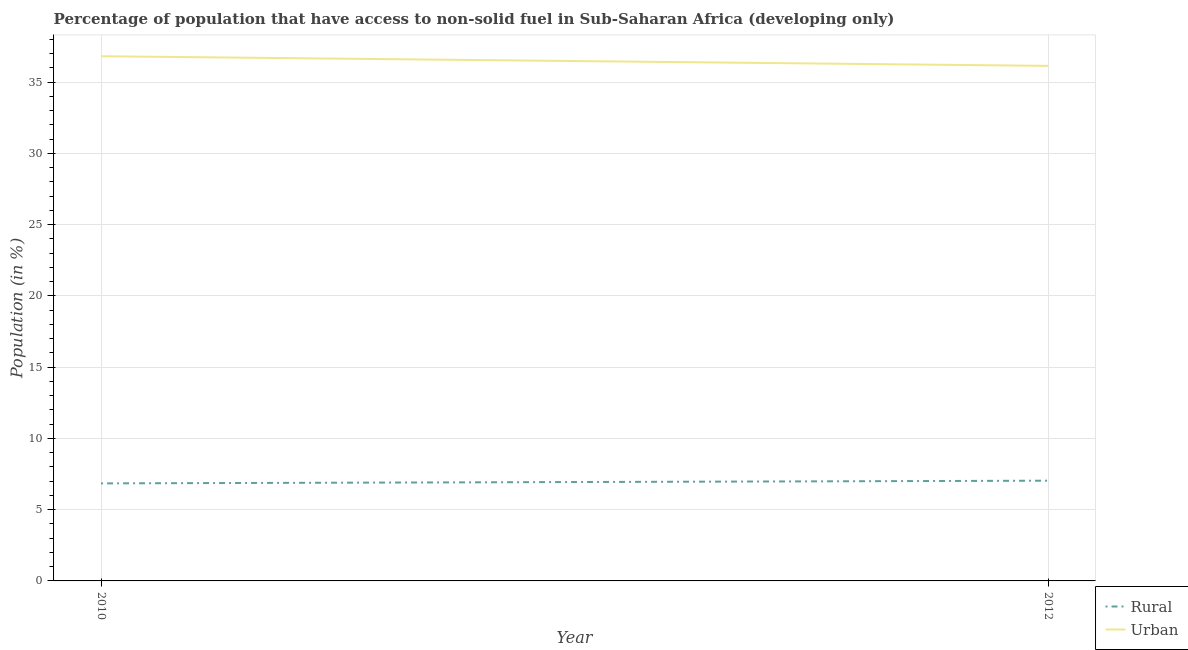Does the line corresponding to urban population intersect with the line corresponding to rural population?
Your answer should be very brief. No. What is the urban population in 2010?
Your response must be concise. 36.81. Across all years, what is the maximum urban population?
Provide a short and direct response. 36.81. Across all years, what is the minimum rural population?
Offer a very short reply. 6.84. In which year was the urban population minimum?
Your answer should be very brief. 2012. What is the total rural population in the graph?
Give a very brief answer. 13.88. What is the difference between the urban population in 2010 and that in 2012?
Keep it short and to the point. 0.68. What is the difference between the urban population in 2012 and the rural population in 2010?
Your response must be concise. 29.29. What is the average urban population per year?
Ensure brevity in your answer.  36.47. In the year 2012, what is the difference between the urban population and rural population?
Your answer should be very brief. 29.1. What is the ratio of the rural population in 2010 to that in 2012?
Offer a terse response. 0.97. Is the rural population in 2010 less than that in 2012?
Offer a terse response. Yes. In how many years, is the urban population greater than the average urban population taken over all years?
Provide a succinct answer. 1. Is the urban population strictly greater than the rural population over the years?
Make the answer very short. Yes. How many lines are there?
Ensure brevity in your answer.  2. Are the values on the major ticks of Y-axis written in scientific E-notation?
Make the answer very short. No. How are the legend labels stacked?
Give a very brief answer. Vertical. What is the title of the graph?
Make the answer very short. Percentage of population that have access to non-solid fuel in Sub-Saharan Africa (developing only). Does "Chemicals" appear as one of the legend labels in the graph?
Ensure brevity in your answer.  No. What is the label or title of the X-axis?
Offer a terse response. Year. What is the label or title of the Y-axis?
Offer a terse response. Population (in %). What is the Population (in %) of Rural in 2010?
Your answer should be compact. 6.84. What is the Population (in %) of Urban in 2010?
Give a very brief answer. 36.81. What is the Population (in %) of Rural in 2012?
Provide a succinct answer. 7.03. What is the Population (in %) in Urban in 2012?
Offer a terse response. 36.14. Across all years, what is the maximum Population (in %) of Rural?
Provide a short and direct response. 7.03. Across all years, what is the maximum Population (in %) of Urban?
Your response must be concise. 36.81. Across all years, what is the minimum Population (in %) in Rural?
Offer a terse response. 6.84. Across all years, what is the minimum Population (in %) in Urban?
Your answer should be very brief. 36.14. What is the total Population (in %) of Rural in the graph?
Your answer should be compact. 13.88. What is the total Population (in %) in Urban in the graph?
Provide a short and direct response. 72.95. What is the difference between the Population (in %) of Rural in 2010 and that in 2012?
Your response must be concise. -0.19. What is the difference between the Population (in %) in Urban in 2010 and that in 2012?
Your response must be concise. 0.68. What is the difference between the Population (in %) of Rural in 2010 and the Population (in %) of Urban in 2012?
Provide a short and direct response. -29.29. What is the average Population (in %) in Rural per year?
Keep it short and to the point. 6.94. What is the average Population (in %) in Urban per year?
Your response must be concise. 36.47. In the year 2010, what is the difference between the Population (in %) of Rural and Population (in %) of Urban?
Your answer should be compact. -29.97. In the year 2012, what is the difference between the Population (in %) of Rural and Population (in %) of Urban?
Provide a short and direct response. -29.1. What is the ratio of the Population (in %) in Rural in 2010 to that in 2012?
Ensure brevity in your answer.  0.97. What is the ratio of the Population (in %) in Urban in 2010 to that in 2012?
Provide a short and direct response. 1.02. What is the difference between the highest and the second highest Population (in %) of Rural?
Give a very brief answer. 0.19. What is the difference between the highest and the second highest Population (in %) of Urban?
Your response must be concise. 0.68. What is the difference between the highest and the lowest Population (in %) in Rural?
Keep it short and to the point. 0.19. What is the difference between the highest and the lowest Population (in %) in Urban?
Ensure brevity in your answer.  0.68. 